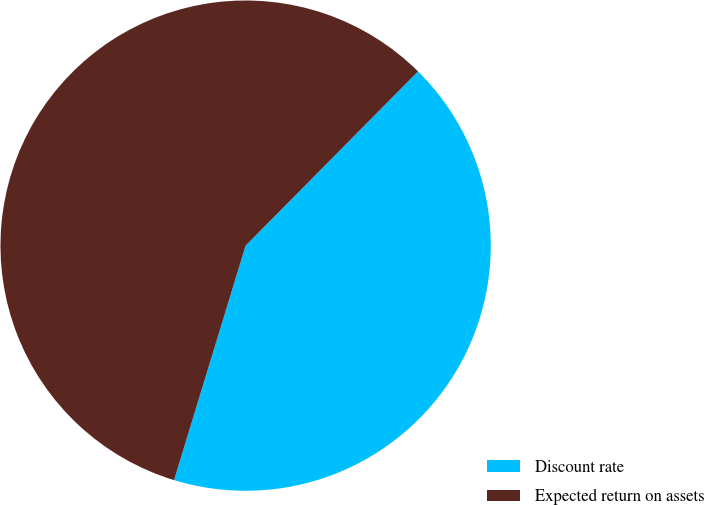<chart> <loc_0><loc_0><loc_500><loc_500><pie_chart><fcel>Discount rate<fcel>Expected return on assets<nl><fcel>42.3%<fcel>57.7%<nl></chart> 